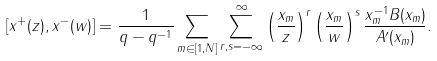Convert formula to latex. <formula><loc_0><loc_0><loc_500><loc_500>\left [ x ^ { + } ( z ) , x ^ { - } ( w ) \right ] = \frac { 1 } { q - q ^ { - 1 } } \sum _ { m \in [ 1 , N ] } \sum _ { r , s = - \infty } ^ { \infty } \left ( \frac { x _ { m } } { z } \right ) ^ { r } \left ( \frac { x _ { m } } { w } \right ) ^ { s } \frac { x _ { m } ^ { - 1 } B ( x _ { m } ) } { A ^ { \prime } ( x _ { m } ) } .</formula> 